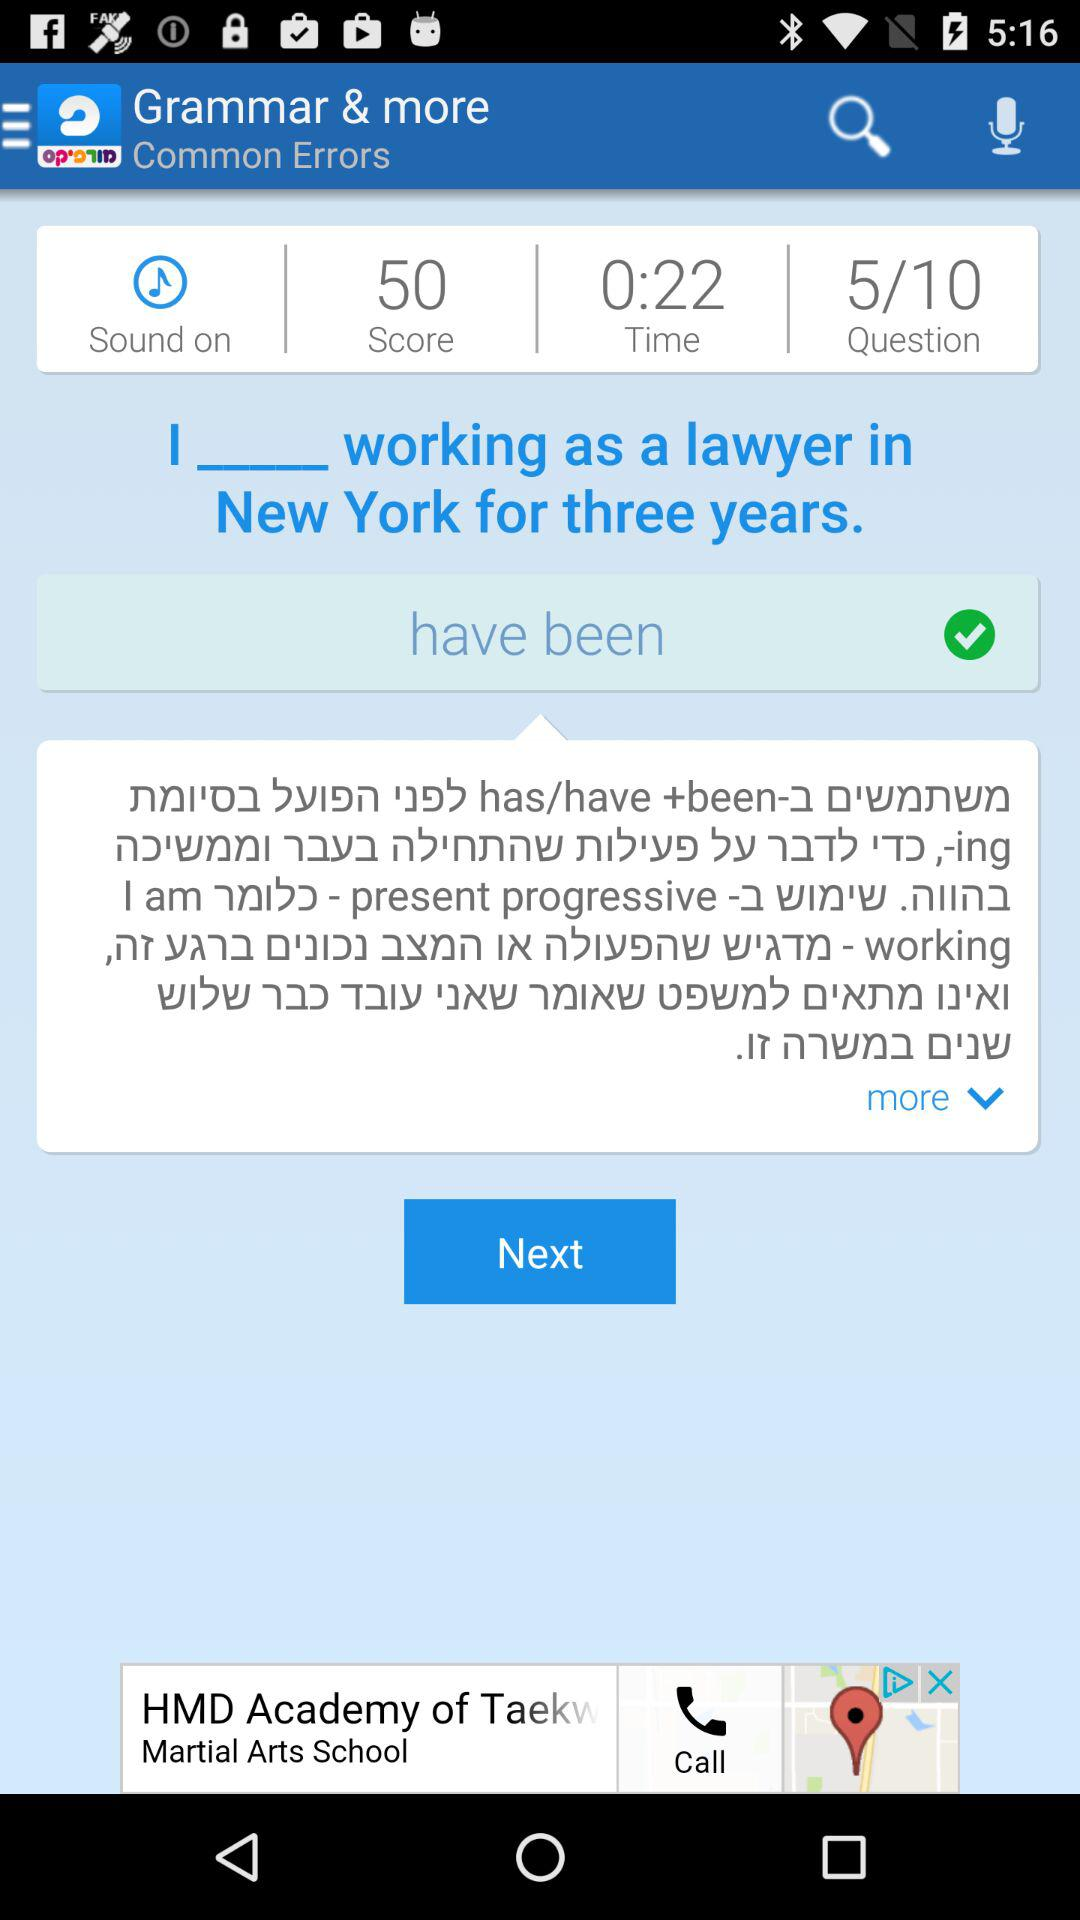What is the score value? The score value is 50. 